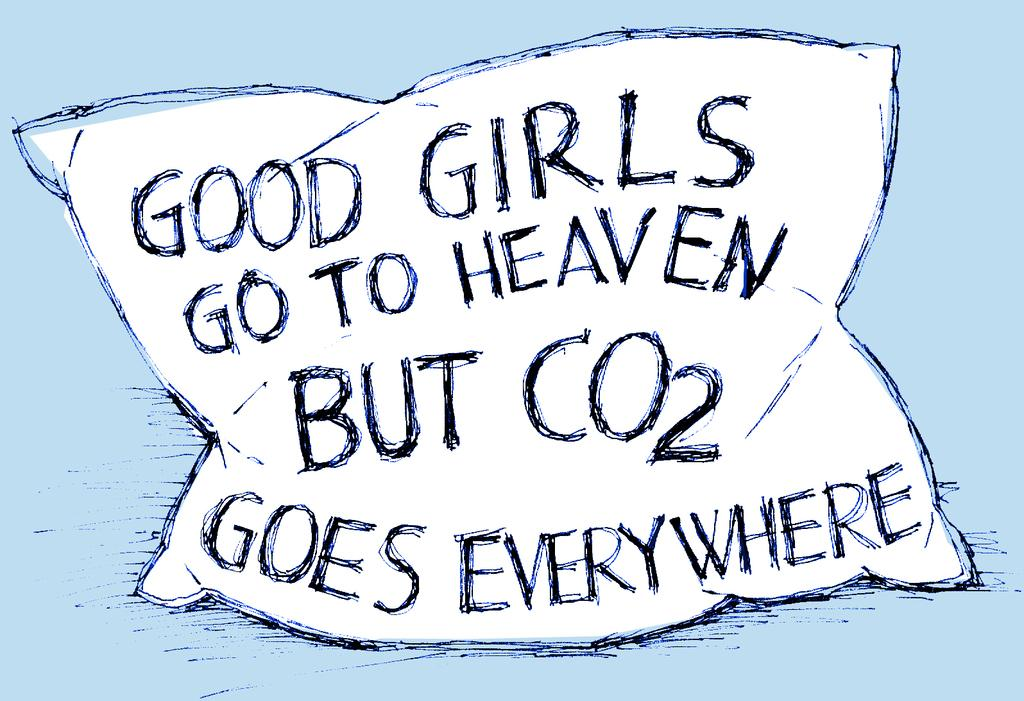What type of image is being described? The image is a sketch. What object is depicted in the sketch? There is a depiction of a pillow in the sketch. Are there any words or letters in the sketch? Yes, there is text present in the sketch. How many light bulbs are visible in the sketch? There are no light bulbs present in the sketch; it features a depiction of a pillow and text. What type of trail is shown in the sketch? There is no trail depicted in the sketch; it only contains a pillow and text. 